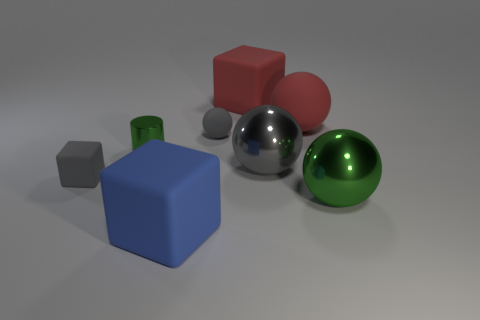Subtract 1 spheres. How many spheres are left? 3 Add 1 blue rubber things. How many objects exist? 9 Subtract all cubes. How many objects are left? 5 Add 2 blue things. How many blue things exist? 3 Subtract 0 purple blocks. How many objects are left? 8 Subtract all red objects. Subtract all big gray metal things. How many objects are left? 5 Add 2 tiny balls. How many tiny balls are left? 3 